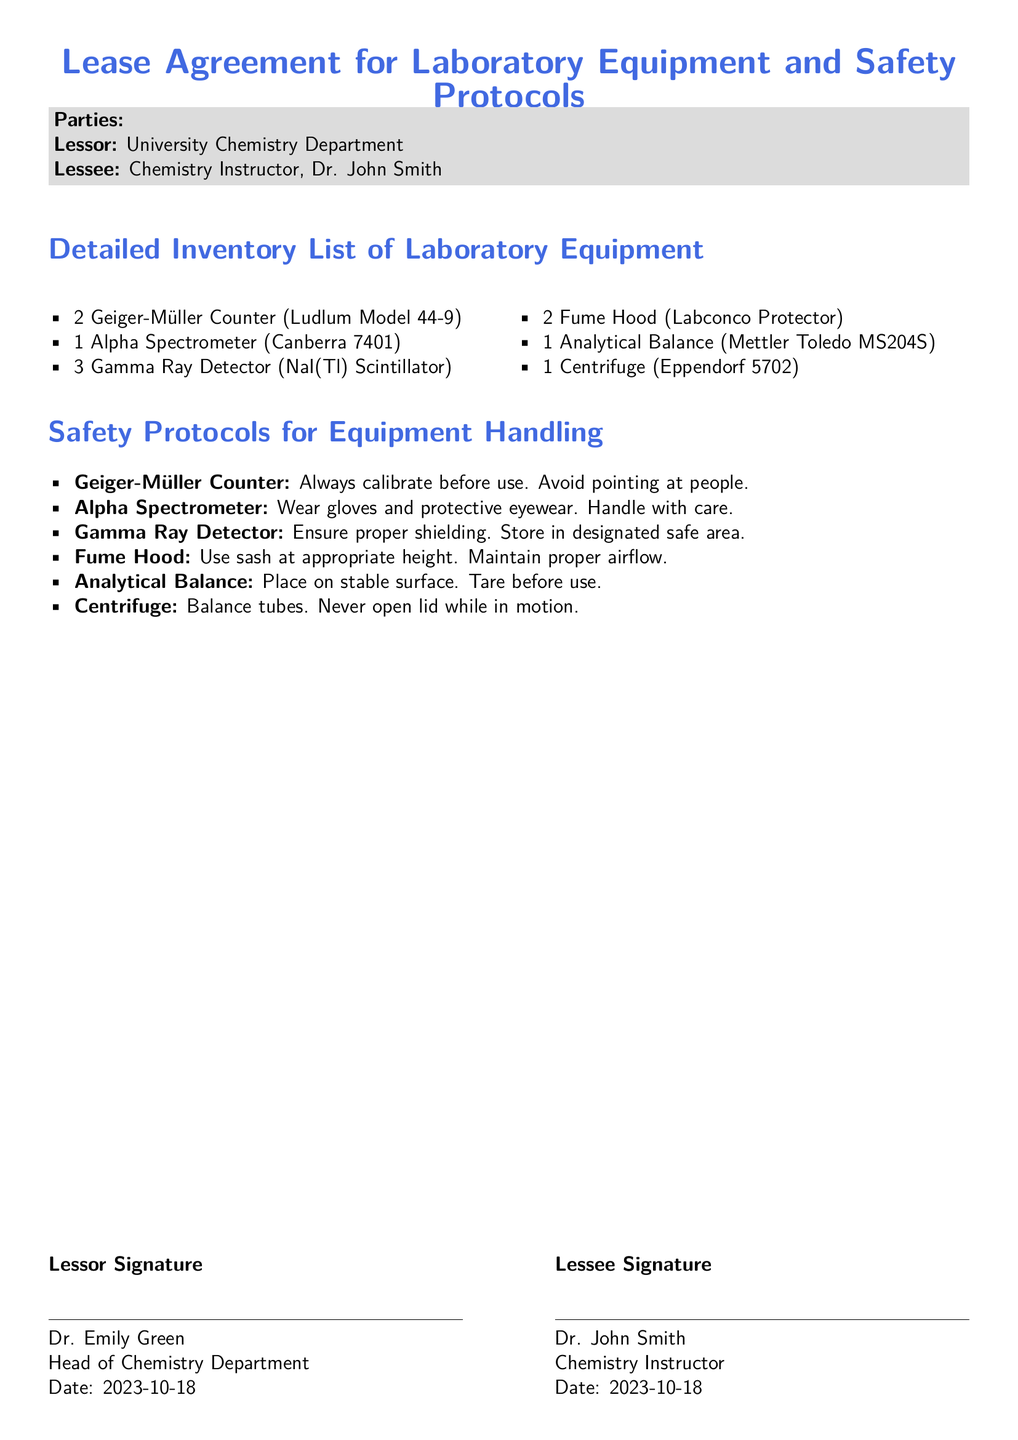What is the date of the lease agreement? The date of the lease agreement is specified at the end of the document in the signature section for both parties.
Answer: 2023-10-18 Who is the lessee? The lessee is mentioned in the parties section of the document as the Chemistry Instructor.
Answer: Dr. John Smith How many Gamma Ray Detectors are listed? The number of Gamma Ray Detectors is provided in the inventory list section under laboratory equipment.
Answer: 3 What is the first item in the Detailed Inventory List? The first item in the Detailed Inventory List is the first laboratory equipment mentioned in the document.
Answer: 2 Geiger-Müller Counter (Ludlum Model 44-9) What must be done before using the Geiger-Müller Counter? The safety protocol for the Geiger-Müller Counter includes a specific requirement that must be carried out before use.
Answer: Always calibrate before use Where should the Gamma Ray Detector be stored? The safety protocol for the Gamma Ray Detector specifies where it should be kept when not in use.
Answer: Designated safe area What is a requirement for the Analytical Balance? The safety protocol for the Analytical Balance mentions operational requirements for its use.
Answer: Place on stable surface Why is balancing tubes important for the centrifuge? The safety protocol for the centrifuge emphasizes the importance of a specific action to prevent accidents, which involves balancing.
Answer: Prevents accidents What is the signature title of the lessor? The document includes the signature section which states the title of the lessor under their name.
Answer: Head of Chemistry Department 